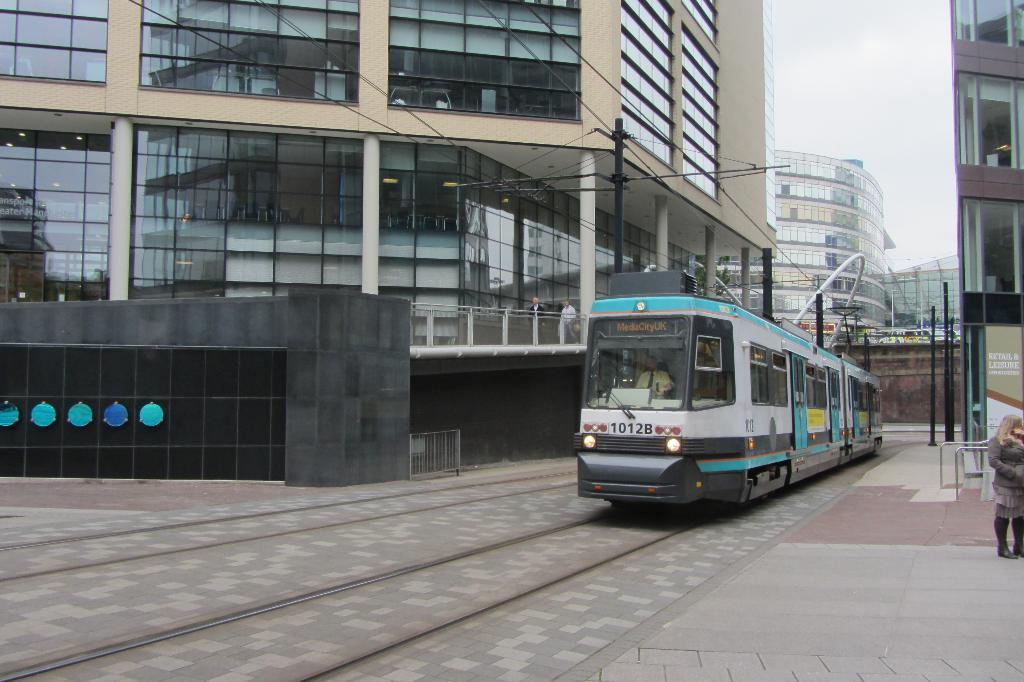What is the main subject in the middle of the image? There is a locomotive in the middle of the image. What can be seen behind the locomotive? There are poles and buildings behind the locomotive. What is visible at the top of the image? Clouds and the sky are visible at the top of the image. What type of twig is being used to control the locomotive in the image? There is no twig present in the image, and the locomotive is not being controlled by any such object. 